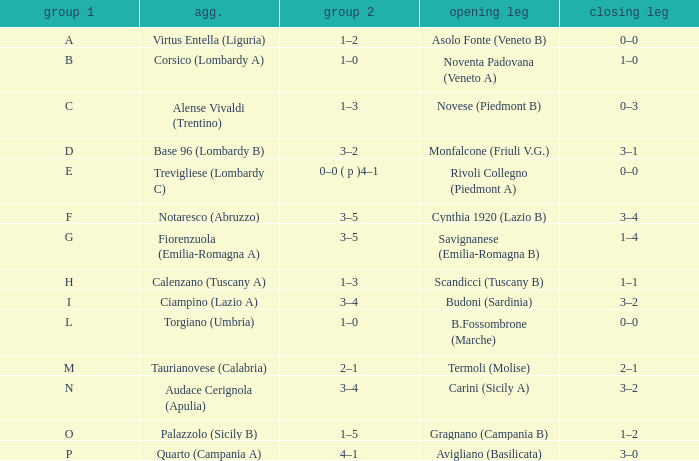What 1st leg has Alense Vivaldi (Trentino) as Agg.? Novese (Piedmont B). 